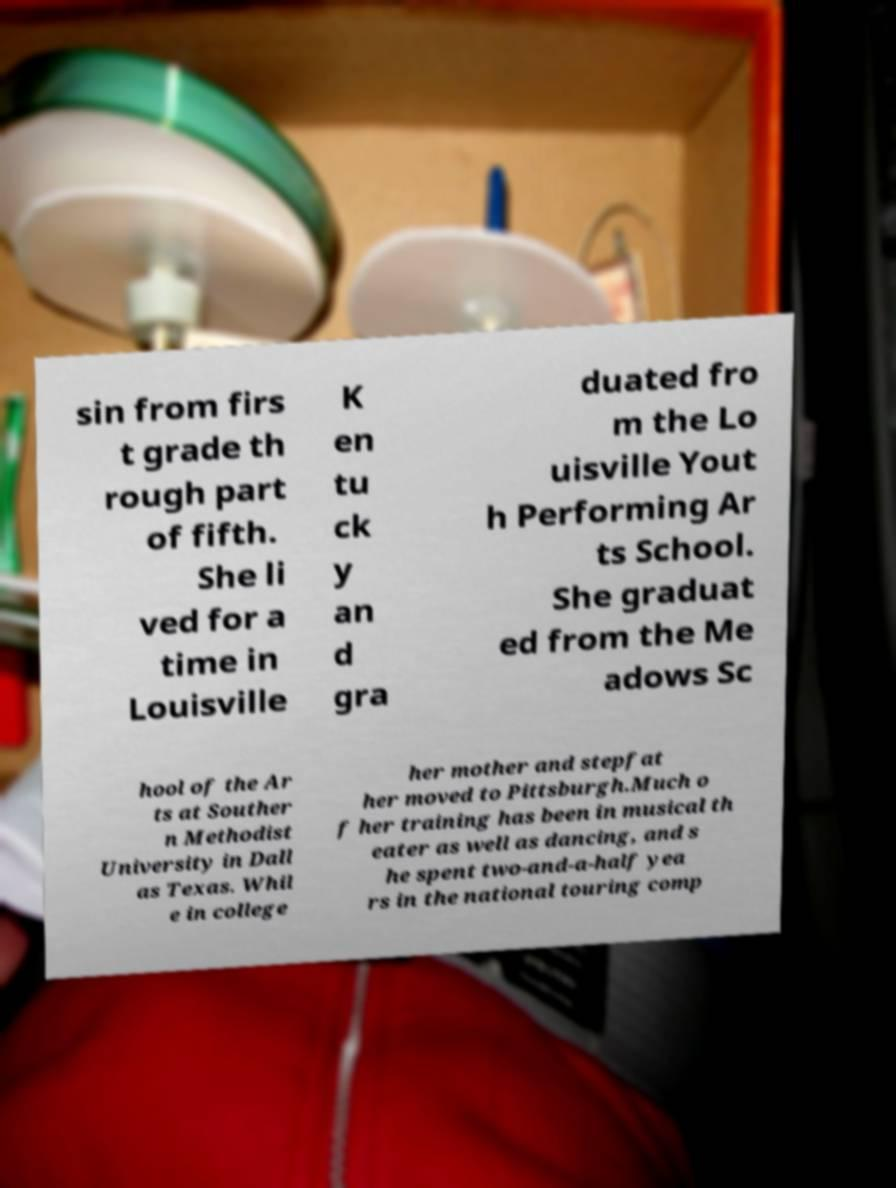Could you assist in decoding the text presented in this image and type it out clearly? sin from firs t grade th rough part of fifth. She li ved for a time in Louisville K en tu ck y an d gra duated fro m the Lo uisville Yout h Performing Ar ts School. She graduat ed from the Me adows Sc hool of the Ar ts at Souther n Methodist University in Dall as Texas. Whil e in college her mother and stepfat her moved to Pittsburgh.Much o f her training has been in musical th eater as well as dancing, and s he spent two-and-a-half yea rs in the national touring comp 